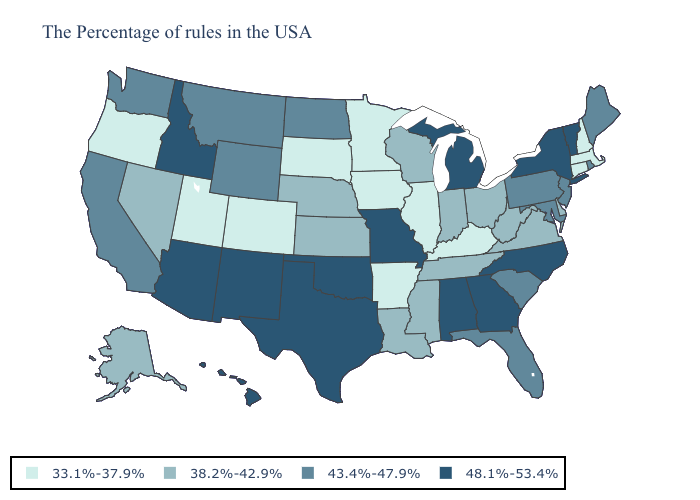Name the states that have a value in the range 38.2%-42.9%?
Give a very brief answer. Delaware, Virginia, West Virginia, Ohio, Indiana, Tennessee, Wisconsin, Mississippi, Louisiana, Kansas, Nebraska, Nevada, Alaska. Which states have the lowest value in the Northeast?
Concise answer only. Massachusetts, New Hampshire, Connecticut. Does South Dakota have the lowest value in the MidWest?
Answer briefly. Yes. Which states have the highest value in the USA?
Give a very brief answer. Vermont, New York, North Carolina, Georgia, Michigan, Alabama, Missouri, Oklahoma, Texas, New Mexico, Arizona, Idaho, Hawaii. What is the value of Tennessee?
Concise answer only. 38.2%-42.9%. What is the highest value in the Northeast ?
Give a very brief answer. 48.1%-53.4%. Name the states that have a value in the range 43.4%-47.9%?
Concise answer only. Maine, Rhode Island, New Jersey, Maryland, Pennsylvania, South Carolina, Florida, North Dakota, Wyoming, Montana, California, Washington. What is the value of Delaware?
Give a very brief answer. 38.2%-42.9%. What is the lowest value in states that border Idaho?
Concise answer only. 33.1%-37.9%. What is the value of Kentucky?
Keep it brief. 33.1%-37.9%. Name the states that have a value in the range 33.1%-37.9%?
Quick response, please. Massachusetts, New Hampshire, Connecticut, Kentucky, Illinois, Arkansas, Minnesota, Iowa, South Dakota, Colorado, Utah, Oregon. What is the highest value in the South ?
Answer briefly. 48.1%-53.4%. Name the states that have a value in the range 33.1%-37.9%?
Quick response, please. Massachusetts, New Hampshire, Connecticut, Kentucky, Illinois, Arkansas, Minnesota, Iowa, South Dakota, Colorado, Utah, Oregon. Which states have the highest value in the USA?
Give a very brief answer. Vermont, New York, North Carolina, Georgia, Michigan, Alabama, Missouri, Oklahoma, Texas, New Mexico, Arizona, Idaho, Hawaii. What is the value of Louisiana?
Keep it brief. 38.2%-42.9%. 